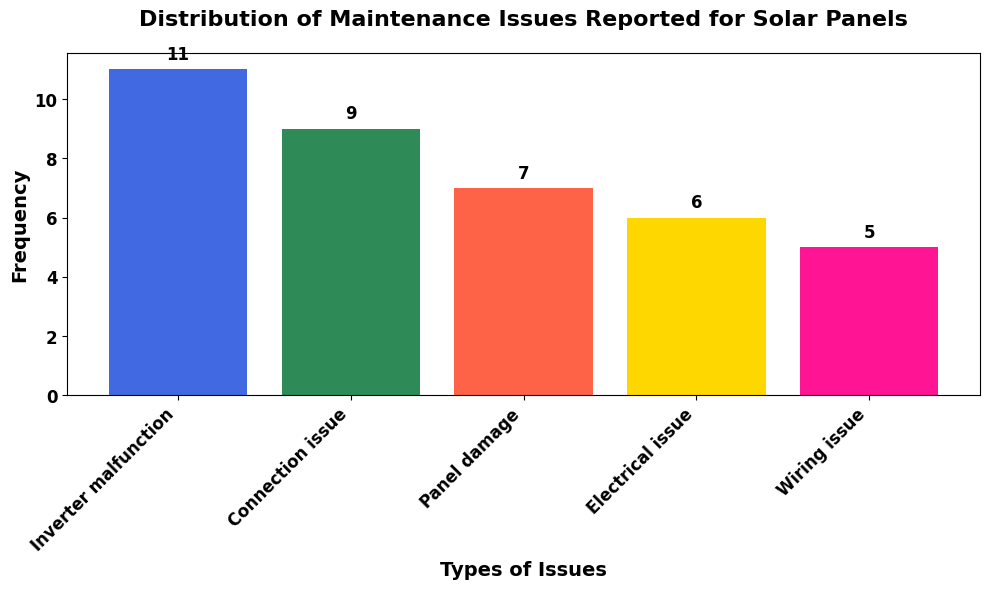What is the most frequently reported maintenance issue? We look at the bar that is the tallest, which represents the issue with the highest frequency.
Answer: Inverter malfunction How many issues were reported for "Panel damage"? We find the corresponding bar for "Panel damage" and read the label above it.
Answer: 6 Which issue was reported less frequently, "Wiring issue" or "Electrical issue"? We compare the heights of the bars for "Wiring issue" and "Electrical issue".
Answer: Wiring issue What is the total number of "Connection issue" and "Electrical issue" reports combined? We locate the counts for both issues and add them together: 7 (Connection issue) + 5 (Electrical issue) = 12.
Answer: 12 How many more times was "Inverter malfunction" reported compared to "Wiring issue"? We find the difference between the counts: 9 (Inverter malfunction) - 4 (Wiring issue) = 5.
Answer: 5 Which issue has the second highest frequency? We find the bar with the second highest height after "Inverter malfunction".
Answer: Connection issue Is the frequency of "Panel damage" greater than or less than the frequency of "Electrical issue"? We compare the heights of the bars for "Panel damage" and "Electrical issue".
Answer: Greater than What is the average number of reports per issue type? We sum all the frequencies and divide by the number of issue types: (9 + 7 + 6 + 5 + 4) / 5 = 31 / 5 = 6.2.
Answer: 6.2 Which issue has the shortest bar and what does this represent? We identify the smallest bar and note that it represents the lowest frequency.
Answer: Wiring issue, 4 If you were to combine the reports of "Inverter malfunction" and "Panel damage," what fraction of total reports would these two issues represent? We add the counts for both issues and divide by the total count: (9 + 6) / 31 = 15 / 31 ≈ 0.48.
Answer: Approximately 0.48 